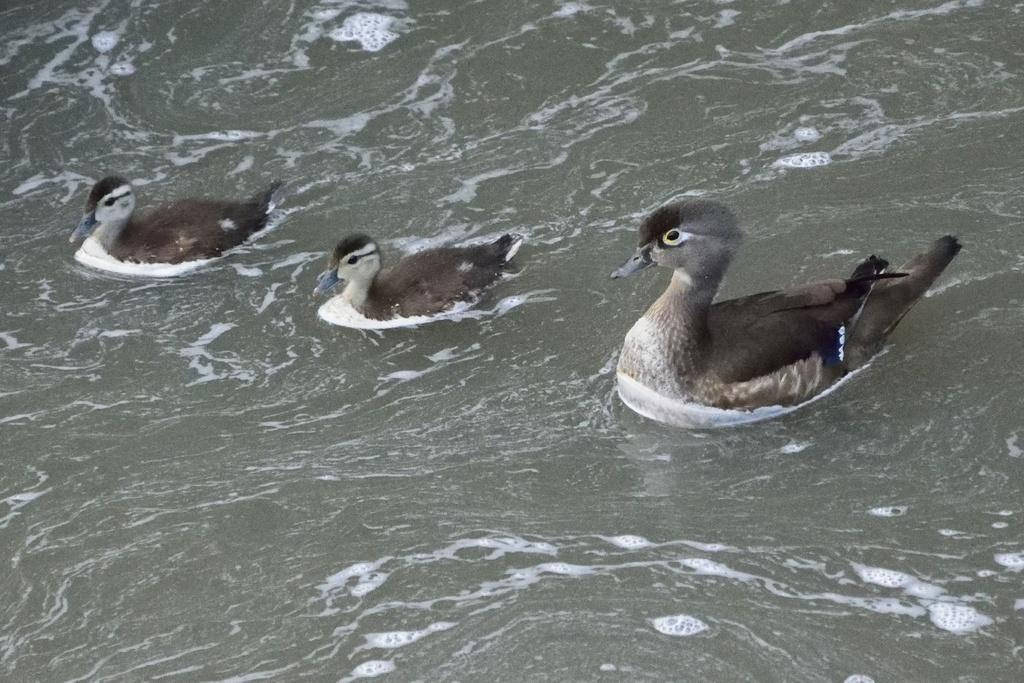How many ducks are in the image? There are three ducks in the image. Where are the ducks located? The ducks are in the water. What else can be seen floating on the water in the image? There is foam floating on the water in the image. What type of beast can be seen hiding in the pocket of the duck in the image? There is no beast present in the image, nor is there any indication of a pocket on the ducks. 